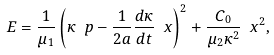Convert formula to latex. <formula><loc_0><loc_0><loc_500><loc_500>E = \frac { 1 } { \mu _ { 1 } } \left ( \kappa \ p - \frac { 1 } { 2 a } \frac { d \kappa } { d t } \ x \right ) ^ { 2 } + \frac { C _ { 0 } } { \mu _ { 2 } \kappa ^ { 2 } } \ x ^ { 2 } ,</formula> 